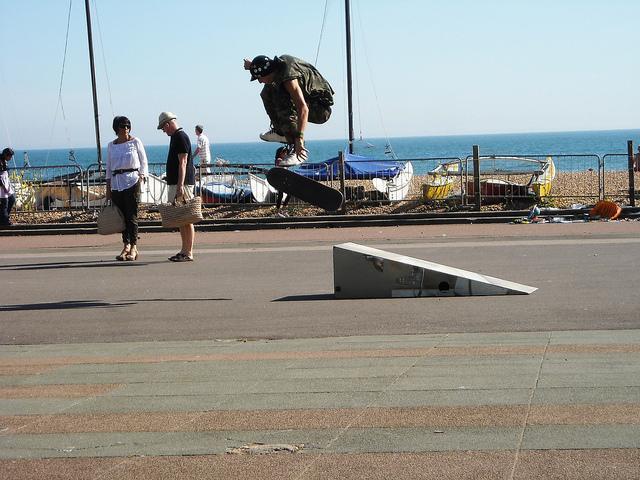How many people are in the picture?
Give a very brief answer. 3. How many books are under the electronic device?
Give a very brief answer. 0. 